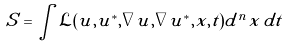<formula> <loc_0><loc_0><loc_500><loc_500>S = \int \mathcal { L } ( u , u ^ { * } , \nabla u , \nabla u ^ { * } , x , t ) d ^ { n } x \, d t</formula> 